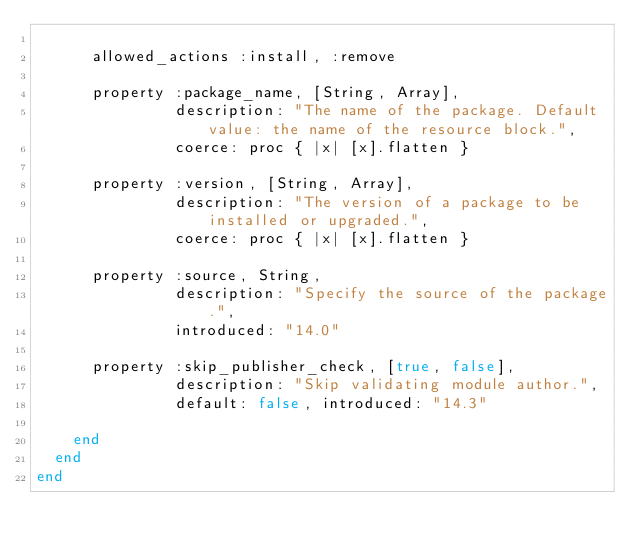Convert code to text. <code><loc_0><loc_0><loc_500><loc_500><_Ruby_>
      allowed_actions :install, :remove

      property :package_name, [String, Array],
               description: "The name of the package. Default value: the name of the resource block.",
               coerce: proc { |x| [x].flatten }

      property :version, [String, Array],
               description: "The version of a package to be installed or upgraded.",
               coerce: proc { |x| [x].flatten }

      property :source, String,
               description: "Specify the source of the package.",
               introduced: "14.0"

      property :skip_publisher_check, [true, false],
               description: "Skip validating module author.",
               default: false, introduced: "14.3"

    end
  end
end
</code> 